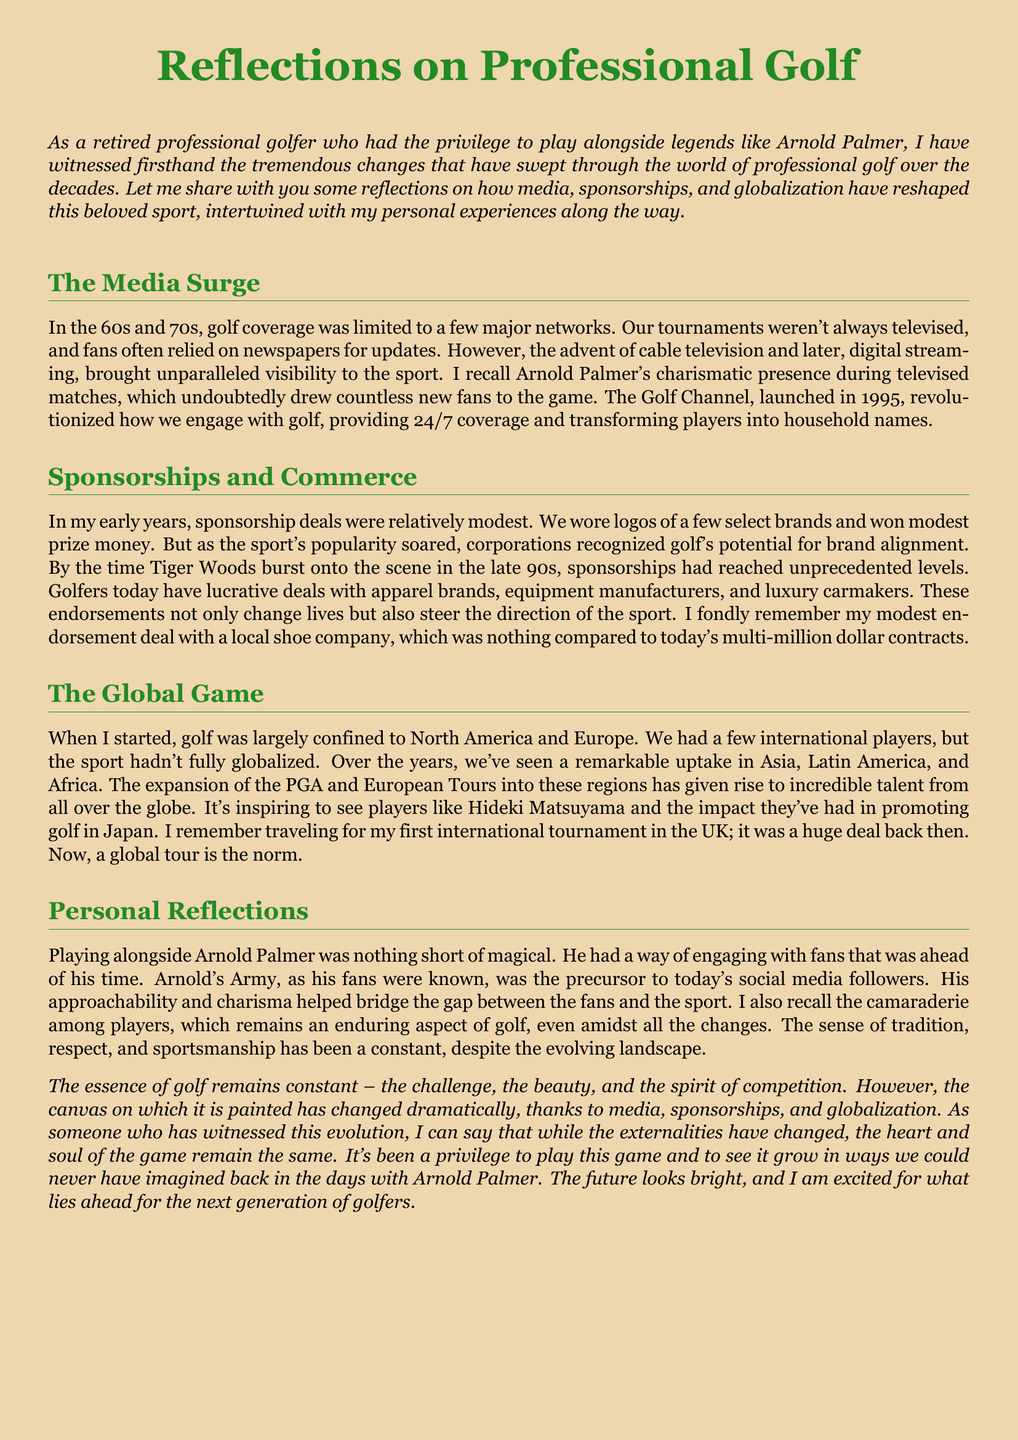What network revolutionized golf television in 1995? The Golf Channel, launched in 1995, provided 24/7 coverage and transformed players into household names.
Answer: The Golf Channel What was the nature of early sponsorship deals in golf? In the early years, sponsorship deals were relatively modest with logos of a few select brands and modest prize money.
Answer: Relatively modest Which player is specifically mentioned as having increased sponsorship levels in the late 90s? Tiger Woods burst onto the scene in the late 90s, and sponsorships reached unprecedented levels afterward.
Answer: Tiger Woods What regions have seen a remarkable uptake in golf globalization? Asia, Latin America, and Africa have experienced significant growth in golf's globalization.
Answer: Asia, Latin America, Africa What term did Arnold Palmer's fans go by? Arnold's Army was the term used for his fans, showcasing his engagement.
Answer: Arnold's Army Which international tournament did the speaker recall traveling for? The speaker remembers traveling for their first international tournament in the UK.
Answer: UK 